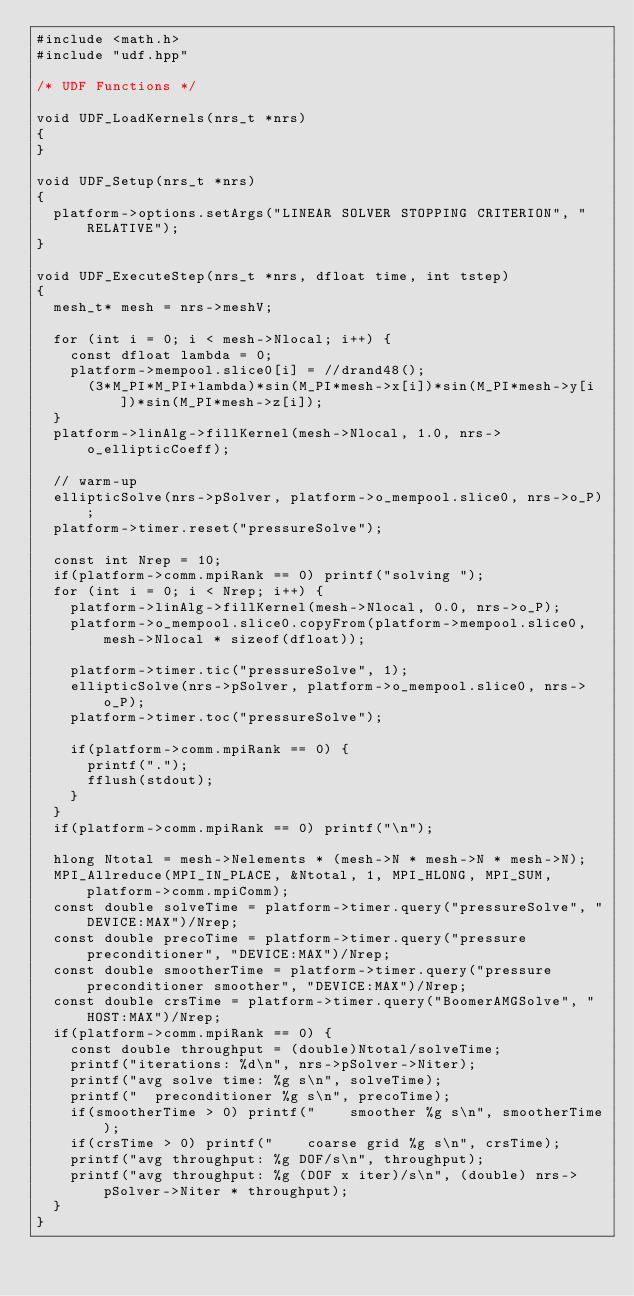<code> <loc_0><loc_0><loc_500><loc_500><_SQL_>#include <math.h>
#include "udf.hpp"

/* UDF Functions */                                                      

void UDF_LoadKernels(nrs_t *nrs)
{
}

void UDF_Setup(nrs_t *nrs)
{
  platform->options.setArgs("LINEAR SOLVER STOPPING CRITERION", "RELATIVE");
}

void UDF_ExecuteStep(nrs_t *nrs, dfloat time, int tstep)
{
  mesh_t* mesh = nrs->meshV;

  for (int i = 0; i < mesh->Nlocal; i++) {
    const dfloat lambda = 0; 
    platform->mempool.slice0[i] = //drand48(); 
      (3*M_PI*M_PI+lambda)*sin(M_PI*mesh->x[i])*sin(M_PI*mesh->y[i])*sin(M_PI*mesh->z[i]);
  }
  platform->linAlg->fillKernel(mesh->Nlocal, 1.0, nrs->o_ellipticCoeff);

  // warm-up
  ellipticSolve(nrs->pSolver, platform->o_mempool.slice0, nrs->o_P);
  platform->timer.reset("pressureSolve");

  const int Nrep = 10; 
  if(platform->comm.mpiRank == 0) printf("solving "); 
  for (int i = 0; i < Nrep; i++) { 
    platform->linAlg->fillKernel(mesh->Nlocal, 0.0, nrs->o_P);
    platform->o_mempool.slice0.copyFrom(platform->mempool.slice0, mesh->Nlocal * sizeof(dfloat));

    platform->timer.tic("pressureSolve", 1);
    ellipticSolve(nrs->pSolver, platform->o_mempool.slice0, nrs->o_P);
    platform->timer.toc("pressureSolve");
    
    if(platform->comm.mpiRank == 0) {
      printf(".");
      fflush(stdout); 
    }
  }
  if(platform->comm.mpiRank == 0) printf("\n"); 

  hlong Ntotal = mesh->Nelements * (mesh->N * mesh->N * mesh->N);
  MPI_Allreduce(MPI_IN_PLACE, &Ntotal, 1, MPI_HLONG, MPI_SUM, platform->comm.mpiComm);
  const double solveTime = platform->timer.query("pressureSolve", "DEVICE:MAX")/Nrep;
  const double precoTime = platform->timer.query("pressure preconditioner", "DEVICE:MAX")/Nrep;
  const double smootherTime = platform->timer.query("pressure preconditioner smoother", "DEVICE:MAX")/Nrep;
  const double crsTime = platform->timer.query("BoomerAMGSolve", "HOST:MAX")/Nrep;
  if(platform->comm.mpiRank == 0) {
    const double throughput = (double)Ntotal/solveTime;
    printf("iterations: %d\n", nrs->pSolver->Niter);
    printf("avg solve time: %g s\n", solveTime);
    printf("  preconditioner %g s\n", precoTime);
    if(smootherTime > 0) printf("    smoother %g s\n", smootherTime);
    if(crsTime > 0) printf("    coarse grid %g s\n", crsTime);
    printf("avg throughput: %g DOF/s\n", throughput);
    printf("avg throughput: %g (DOF x iter)/s\n", (double) nrs->pSolver->Niter * throughput);
  }
}
</code> 